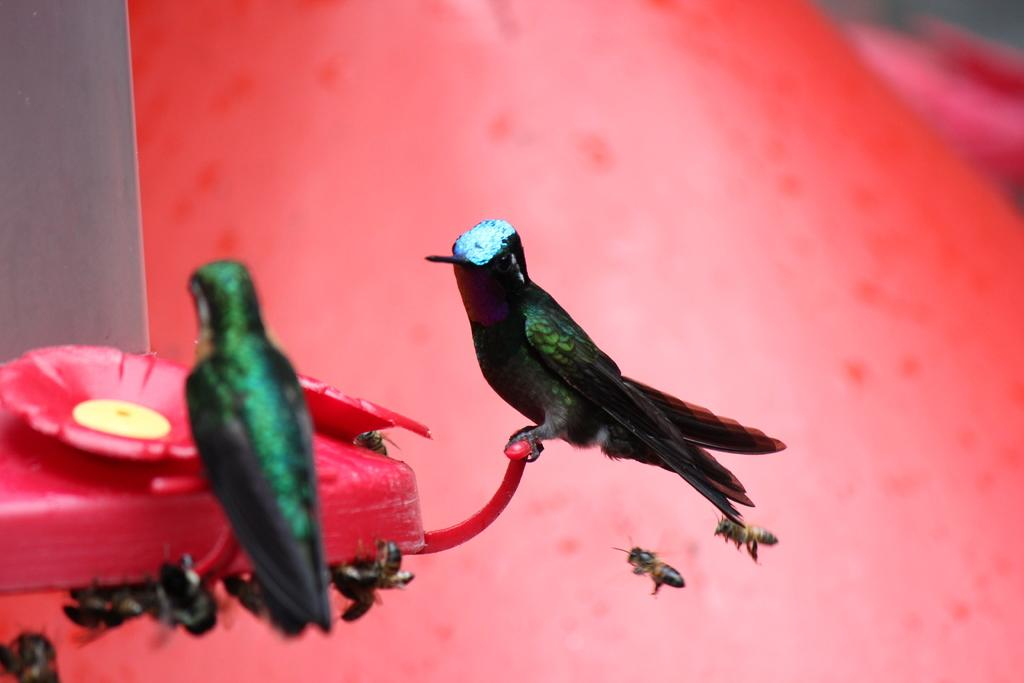What is the main subject of the image? There is an object in the image. What is on the object? There are two birds on the object. What else can be seen around the object? There are honey bees around the object. How much money is being exchanged between the birds in the image? There is no money being exchanged in the image; it features two birds on an object with honey bees around it. 